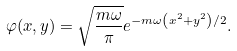<formula> <loc_0><loc_0><loc_500><loc_500>\varphi ( x , y ) = \sqrt { \frac { m \omega } { \pi } } e ^ { - m \omega \left ( x ^ { 2 } + y ^ { 2 } \right ) / 2 } .</formula> 